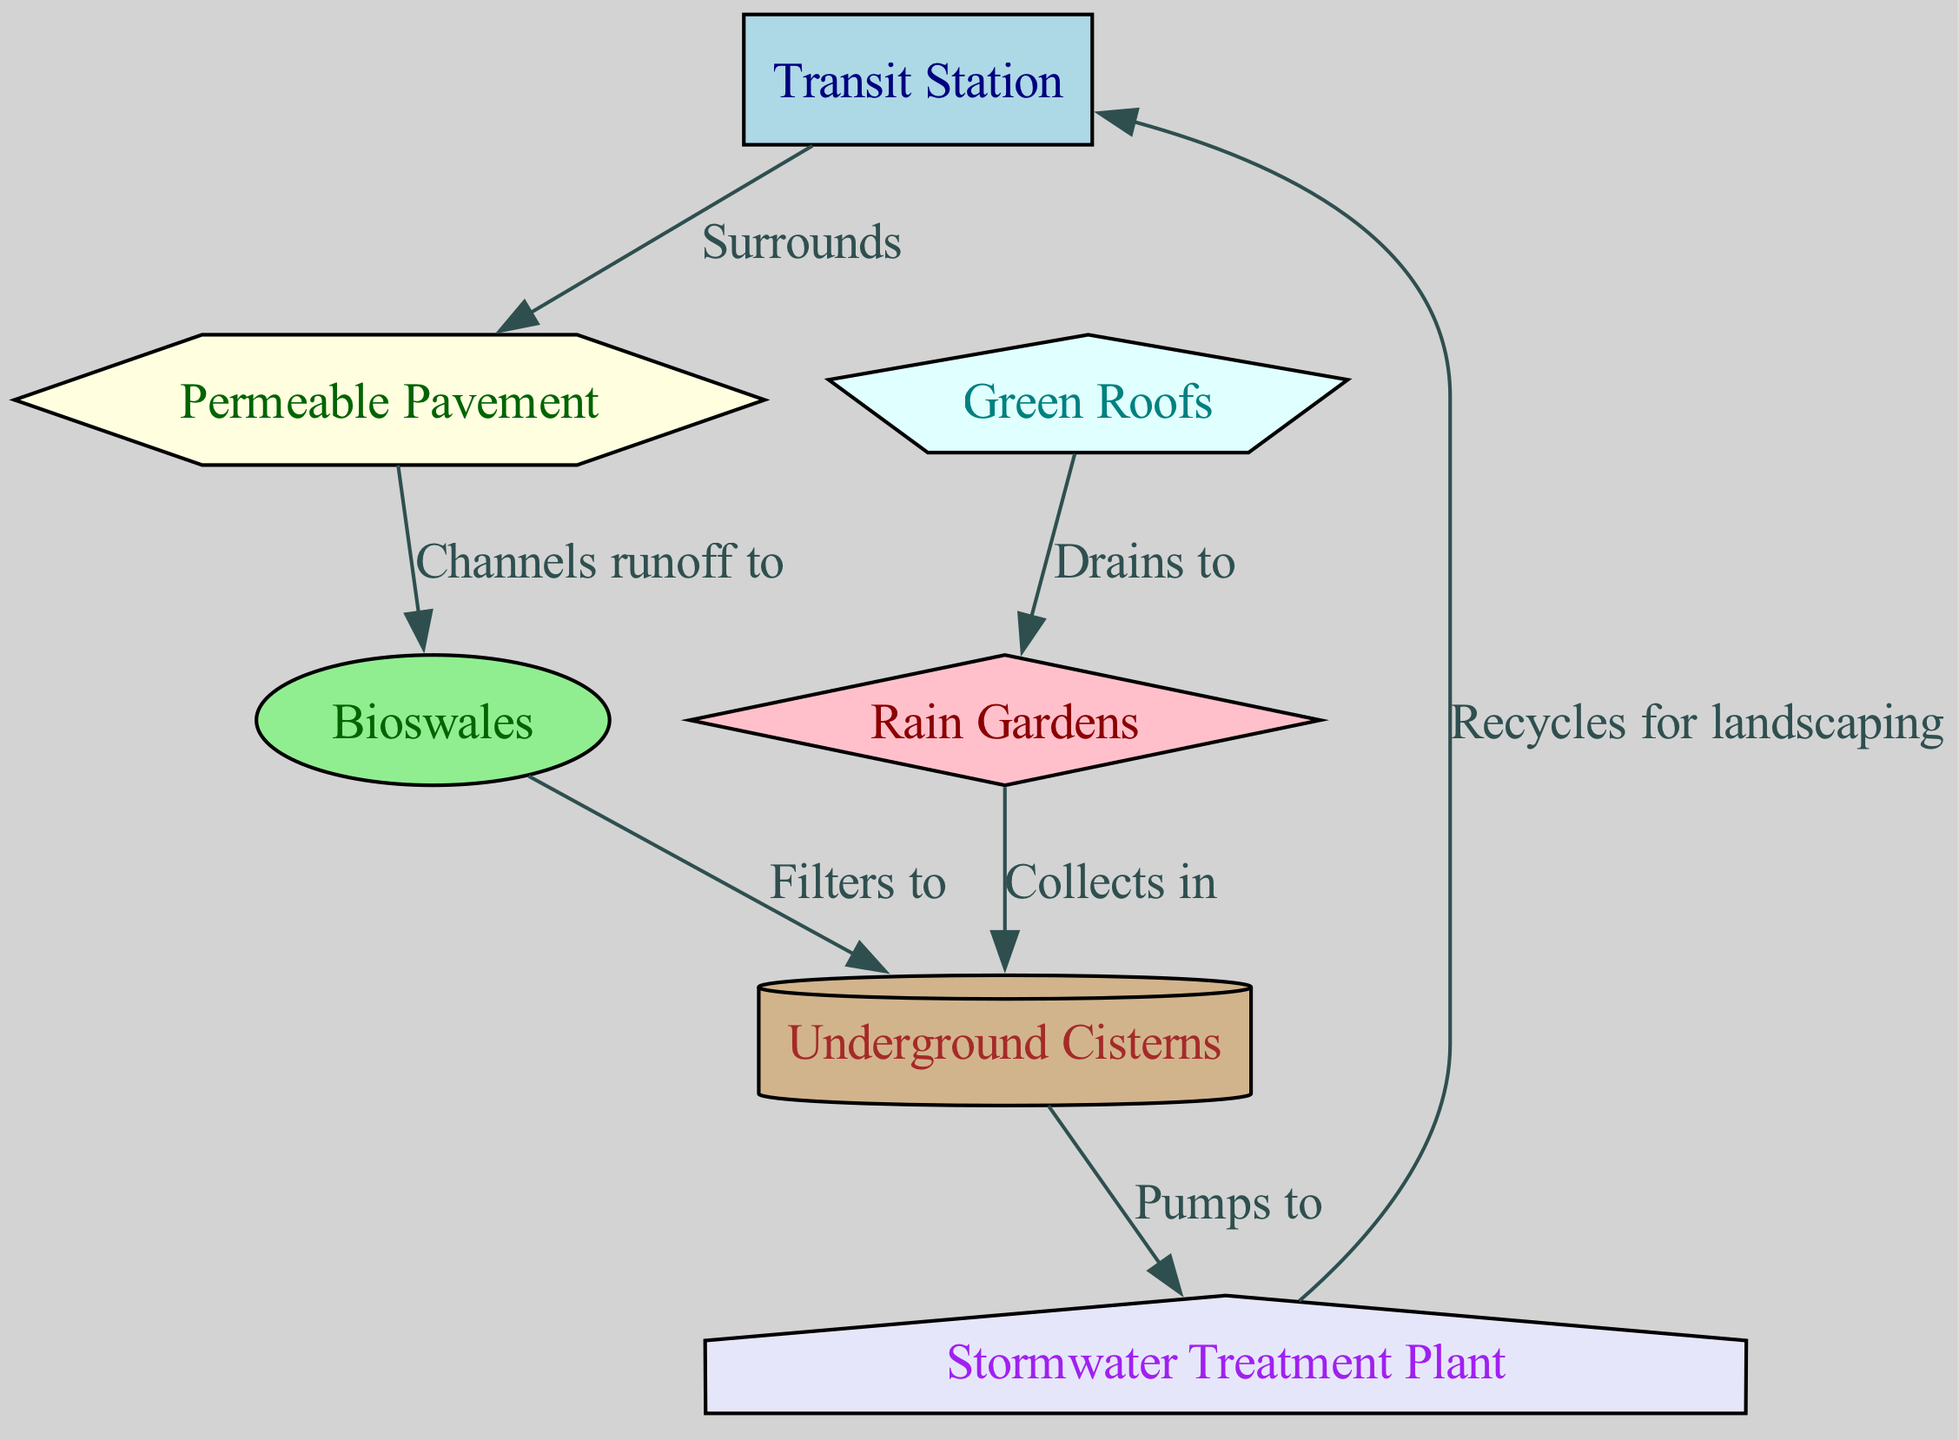What is the total number of nodes in the diagram? The diagram lists seven distinct elements: Transit Station, Permeable Pavement, Bioswales, Rain Gardens, Green Roofs, Underground Cisterns, and Stormwater Treatment Plant. We count each of these elements to determine the total number of nodes.
Answer: Seven What elements surround the Transit Station? According to the diagram, only one element surrounds the Transit Station, which is the Permeable Pavement. This can be directly identified from the edge labeled "Surrounds" connecting these two nodes.
Answer: Permeable Pavement Which element collects water and sends it to underground cisterns? The Rain Gardens are shown in the diagram as collecting water and directing it to the Underground Cisterns. The relationship is established by the edge labeled "Collects in."
Answer: Rain Gardens How many connections does the Underground Cisterns have? The Underground Cisterns have two incoming connections: one from the Bioswales (labeled "Filters to") and one from the Rain Gardens (labeled "Collects in"), and one outgoing connection to the Stormwater Treatment Plant (labeled "Pumps to"). We add the connections to find a total of three connections.
Answer: Three What is the flow of water from the Green Roofs to the Transit Station? The flow starts at the Green Roofs, which drain water to the Rain Gardens. The Rain Gardens then collect water into the Underground Cisterns. From there, the Underground Cisterns pump the water to the Stormwater Treatment Plant, and finally, the treated water is recycled back to the Transit Station for landscaping. The sequence of connections clearly outlines this flow.
Answer: Green Roofs to Rain Gardens to Underground Cisterns to Stormwater Treatment Plant to Transit Station Which node serves as a treatment facility in the system? The node that serves as a treatment facility is the Stormwater Treatment Plant, which is identified by its role in the diagram as the step that processes stormwater before it is recycled back to the Transit Station.
Answer: Stormwater Treatment Plant What type of infrastructure does the Bioswales represent? In this diagram, Bioswales represent a type of green infrastructure designed to manage and filter stormwater runoff so that it can be effectively handled in the overall system. This is evidenced by their direct connection to the Underground Cisterns for filtering and directing water.
Answer: Green Infrastructure Which node primarily recycles water for landscaping purposes? The Transit Station is specified as the node that recycles water for landscaping, receiving treated water from the Stormwater Treatment Plant, as indicated by the edge labeled "Recycles for landscaping."
Answer: Transit Station 